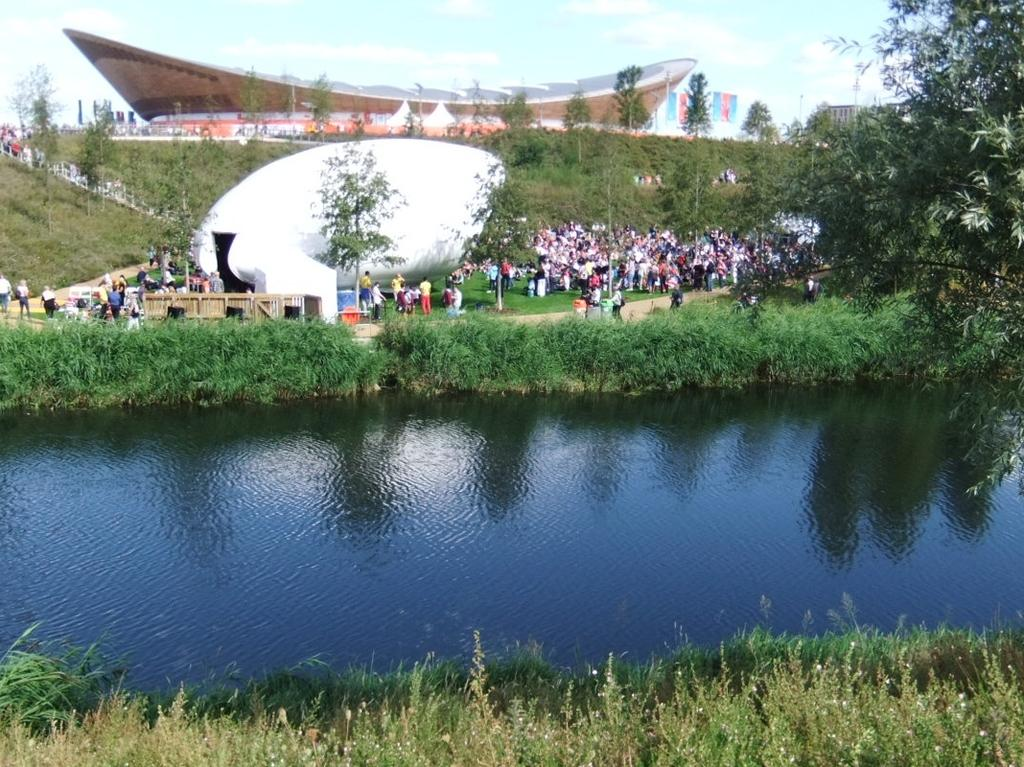What type of natural elements can be seen in the image? There are trees and a lake in the image. Are there any living beings present in the image? Yes, there are persons in the image. What is the landscape surrounding the lake like? There are plants surrounding the lake. What can be seen in the middle of the image? There are architectures in the middle of the image. What is visible at the top of the image? The sky is visible at the top of the image. Can you hear the persons in the image laughing? The image is a still picture, so it does not capture any sounds, including laughter. Are there any railway tracks visible in the image? There are no railway tracks present in the image. 